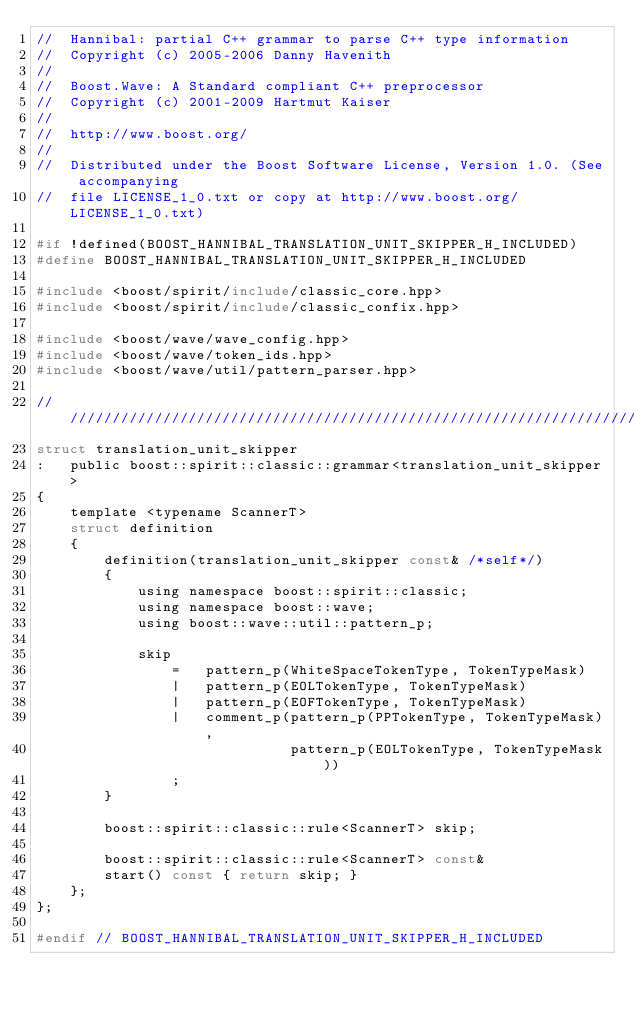Convert code to text. <code><loc_0><loc_0><loc_500><loc_500><_C_>//  Hannibal: partial C++ grammar to parse C++ type information
//  Copyright (c) 2005-2006 Danny Havenith
// 
//  Boost.Wave: A Standard compliant C++ preprocessor
//  Copyright (c) 2001-2009 Hartmut Kaiser
// 
//  http://www.boost.org/
//
//  Distributed under the Boost Software License, Version 1.0. (See accompanying 
//  file LICENSE_1_0.txt or copy at http://www.boost.org/LICENSE_1_0.txt)

#if !defined(BOOST_HANNIBAL_TRANSLATION_UNIT_SKIPPER_H_INCLUDED)
#define BOOST_HANNIBAL_TRANSLATION_UNIT_SKIPPER_H_INCLUDED

#include <boost/spirit/include/classic_core.hpp>
#include <boost/spirit/include/classic_confix.hpp>

#include <boost/wave/wave_config.hpp>
#include <boost/wave/token_ids.hpp>
#include <boost/wave/util/pattern_parser.hpp>

///////////////////////////////////////////////////////////////////////////////
struct translation_unit_skipper
:   public boost::spirit::classic::grammar<translation_unit_skipper>
{
    template <typename ScannerT>
    struct definition
    {
        definition(translation_unit_skipper const& /*self*/)
        {
            using namespace boost::spirit::classic;
            using namespace boost::wave;
            using boost::wave::util::pattern_p;
            
            skip
                =   pattern_p(WhiteSpaceTokenType, TokenTypeMask)
                |   pattern_p(EOLTokenType, TokenTypeMask)
                |   pattern_p(EOFTokenType, TokenTypeMask)
                |   comment_p(pattern_p(PPTokenType, TokenTypeMask), 
                              pattern_p(EOLTokenType, TokenTypeMask))
                ;
        }

        boost::spirit::classic::rule<ScannerT> skip;

        boost::spirit::classic::rule<ScannerT> const&
        start() const { return skip; }
    };
};

#endif // BOOST_HANNIBAL_TRANSLATION_UNIT_SKIPPER_H_INCLUDED
</code> 